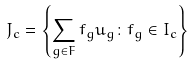<formula> <loc_0><loc_0><loc_500><loc_500>J _ { c } = \left \{ \sum _ { g \in F } f _ { g } u _ { g } \colon f _ { g } \in I _ { c } \right \}</formula> 